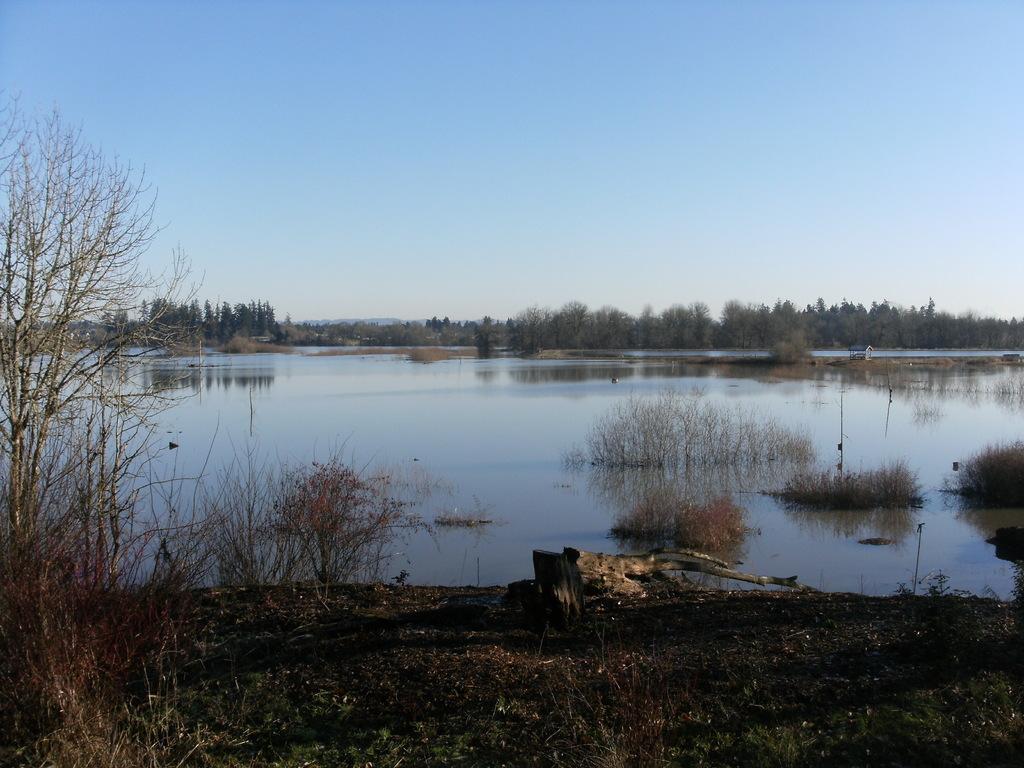Please provide a concise description of this image. In this picture there is grassland at the bottom side of the image and there is water in the center of the image, there are trees in the background area of the image. 